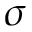<formula> <loc_0><loc_0><loc_500><loc_500>\sigma</formula> 